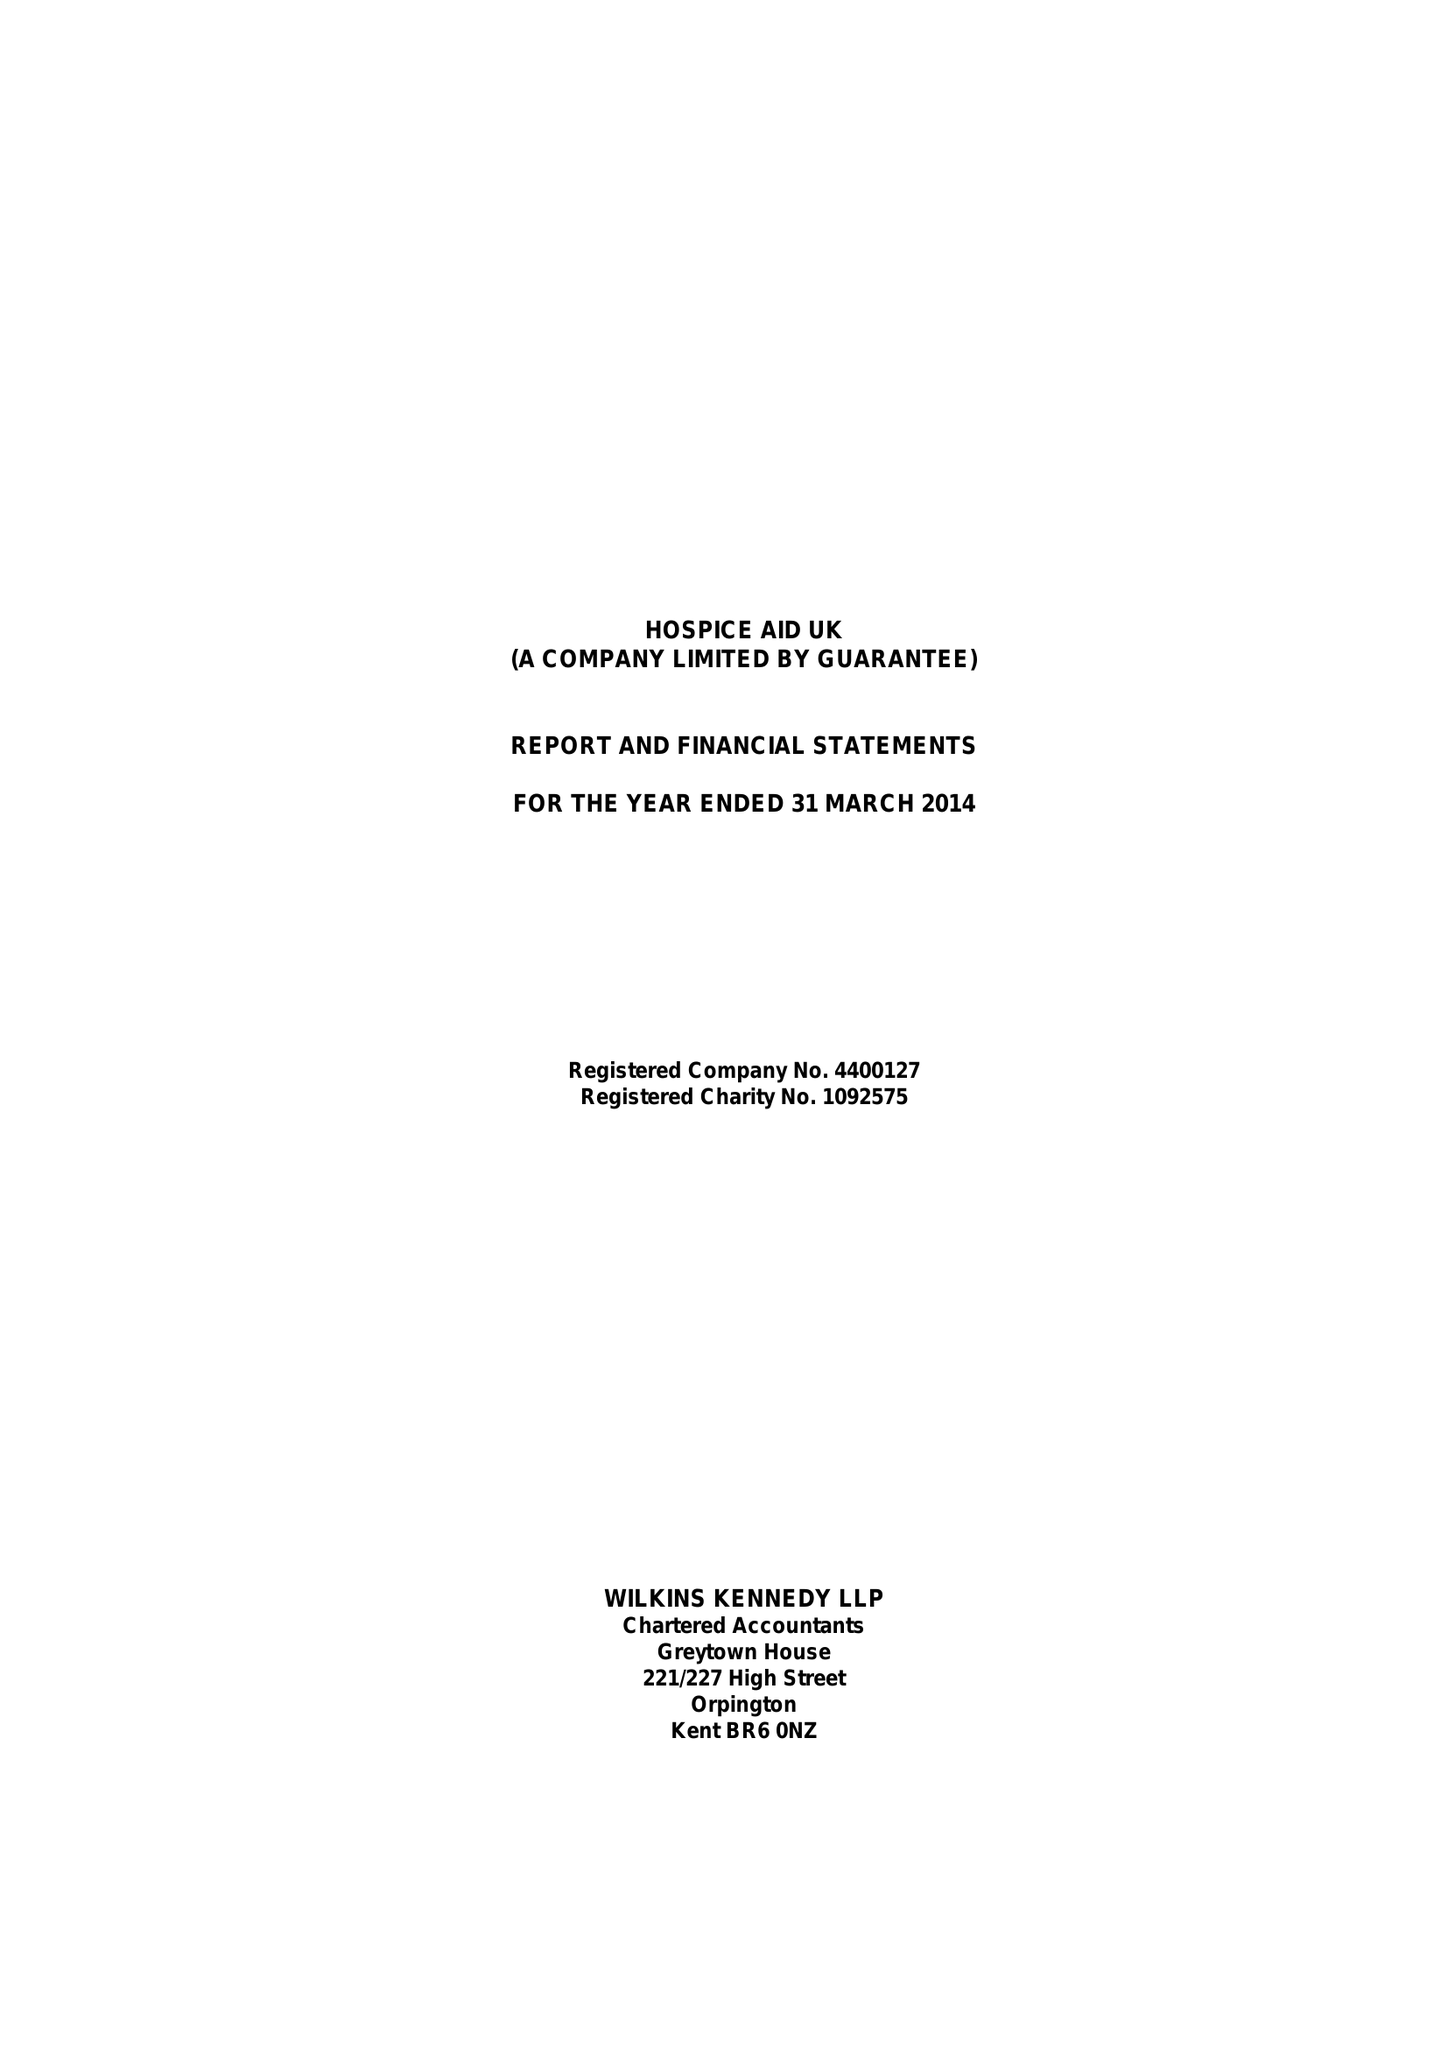What is the value for the charity_name?
Answer the question using a single word or phrase. Hospice Aid Uk 